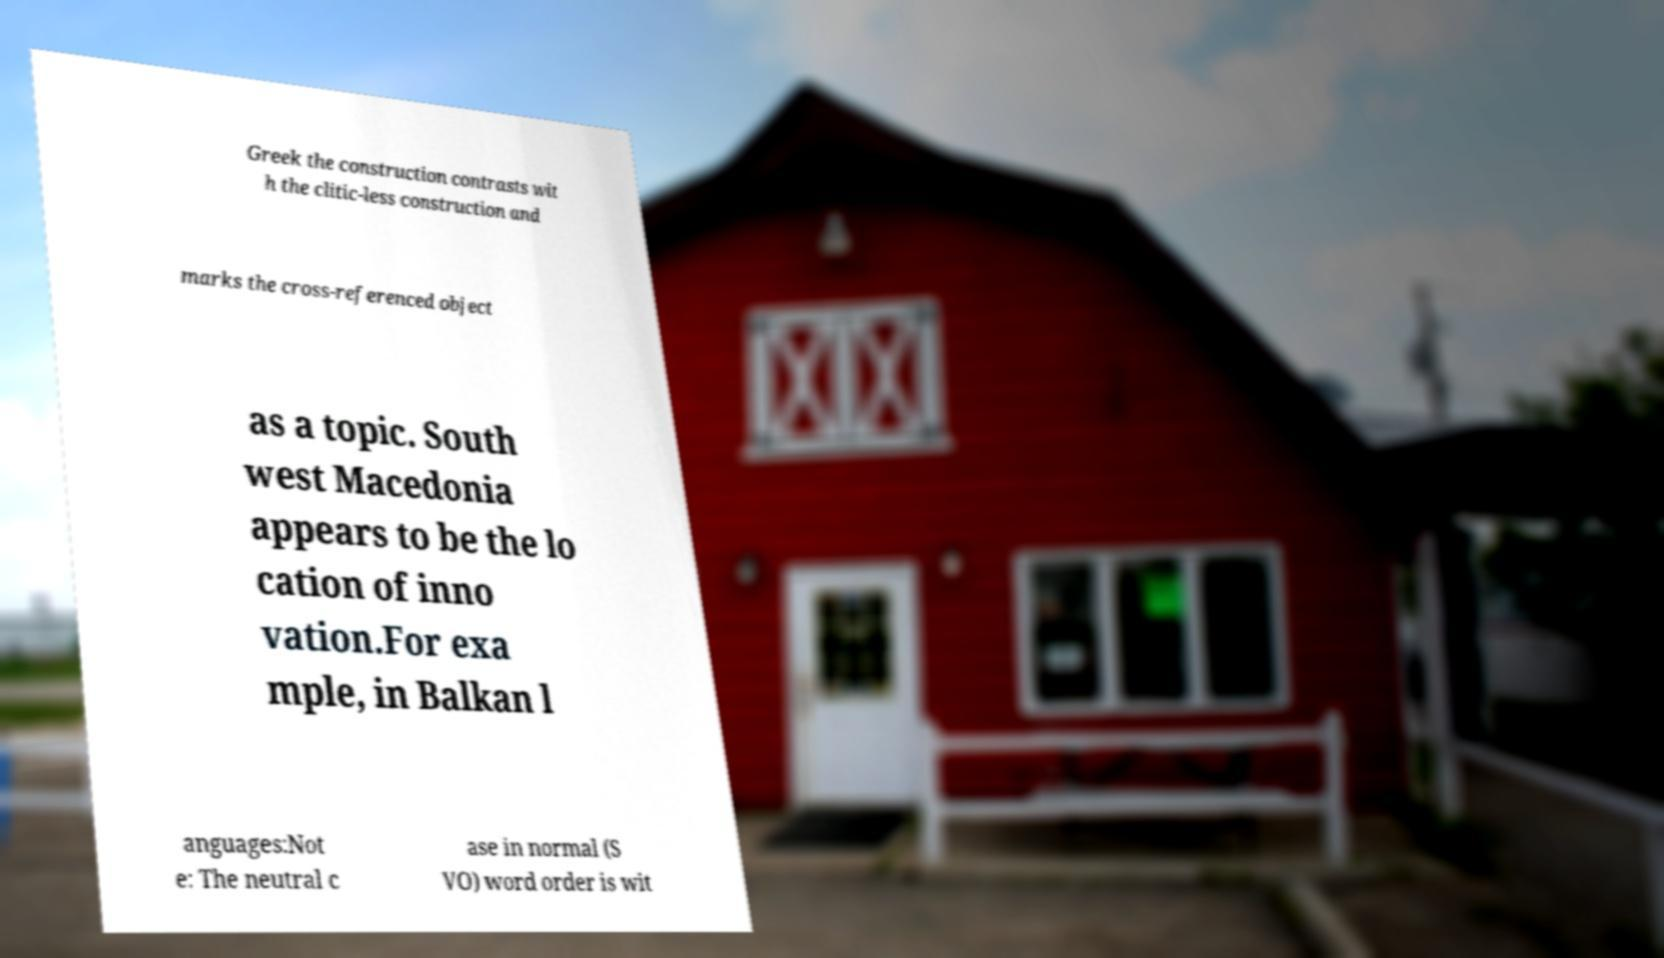What messages or text are displayed in this image? I need them in a readable, typed format. Greek the construction contrasts wit h the clitic-less construction and marks the cross-referenced object as a topic. South west Macedonia appears to be the lo cation of inno vation.For exa mple, in Balkan l anguages:Not e: The neutral c ase in normal (S VO) word order is wit 